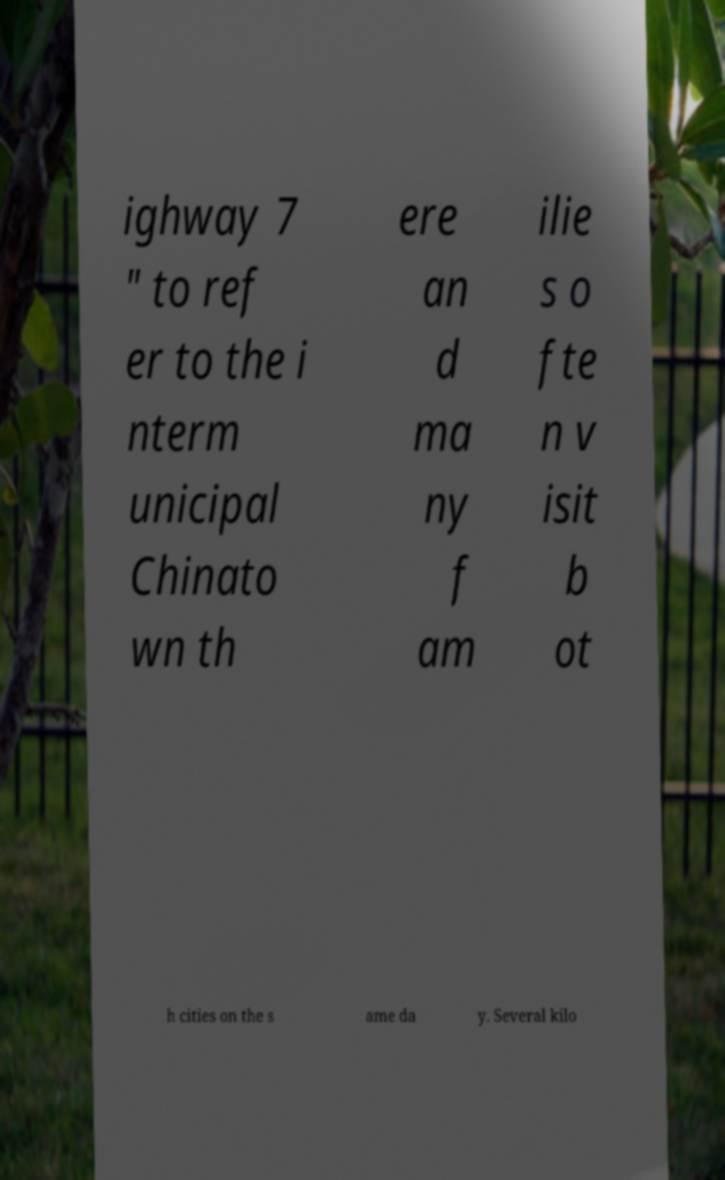For documentation purposes, I need the text within this image transcribed. Could you provide that? ighway 7 " to ref er to the i nterm unicipal Chinato wn th ere an d ma ny f am ilie s o fte n v isit b ot h cities on the s ame da y. Several kilo 